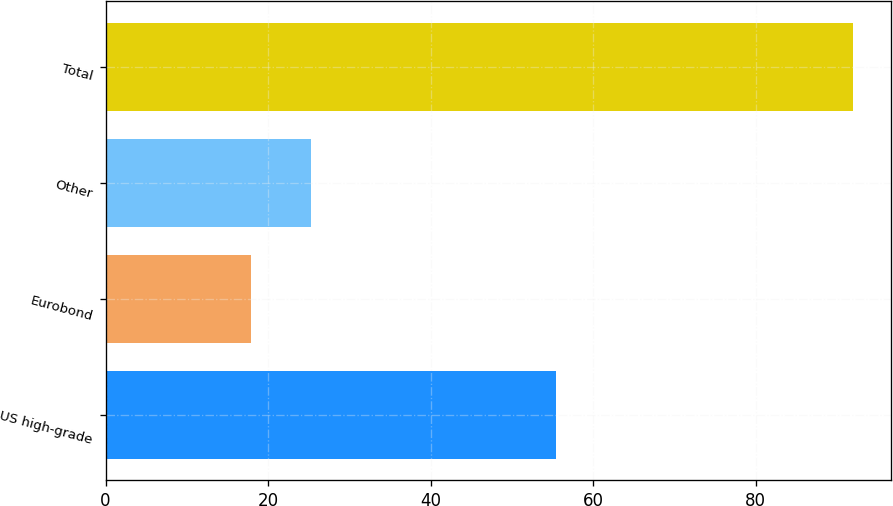Convert chart. <chart><loc_0><loc_0><loc_500><loc_500><bar_chart><fcel>US high-grade<fcel>Eurobond<fcel>Other<fcel>Total<nl><fcel>55.4<fcel>17.9<fcel>25.31<fcel>92<nl></chart> 